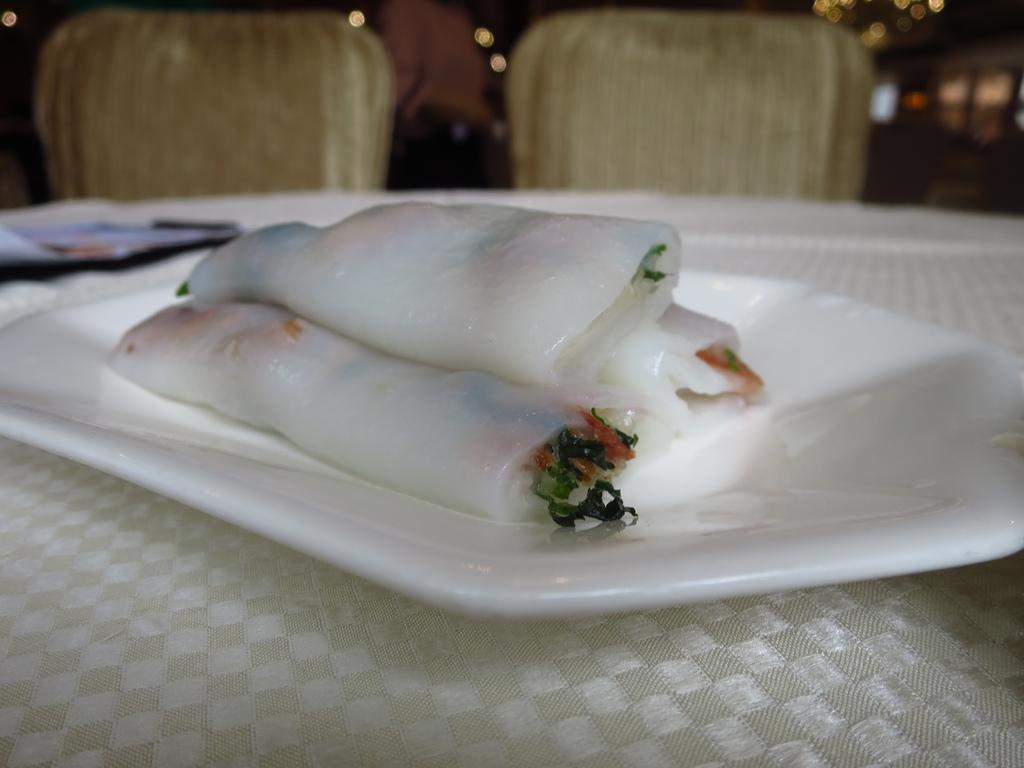Can you describe this image briefly? In the picture we can see a table with a white color plate on it, on it we can see a food item and behind the table we can see two chairs. 